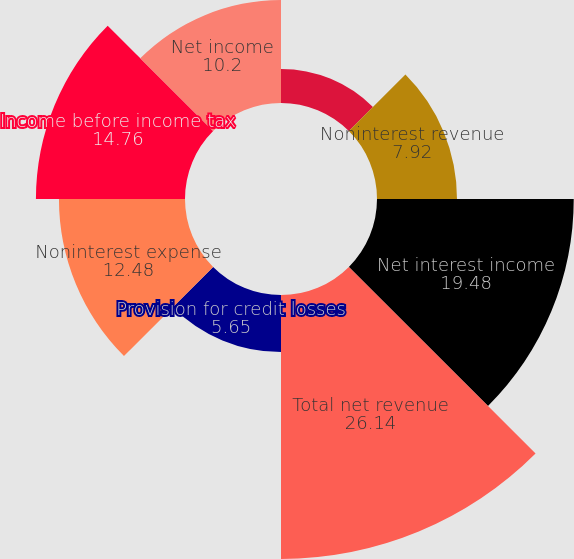<chart> <loc_0><loc_0><loc_500><loc_500><pie_chart><fcel>Year ended December 31 (in<fcel>Noninterest revenue<fcel>Net interest income<fcel>Total net revenue<fcel>Provision for credit losses<fcel>Noninterest expense<fcel>Income before income tax<fcel>Net income<nl><fcel>3.37%<fcel>7.92%<fcel>19.48%<fcel>26.14%<fcel>5.65%<fcel>12.48%<fcel>14.76%<fcel>10.2%<nl></chart> 